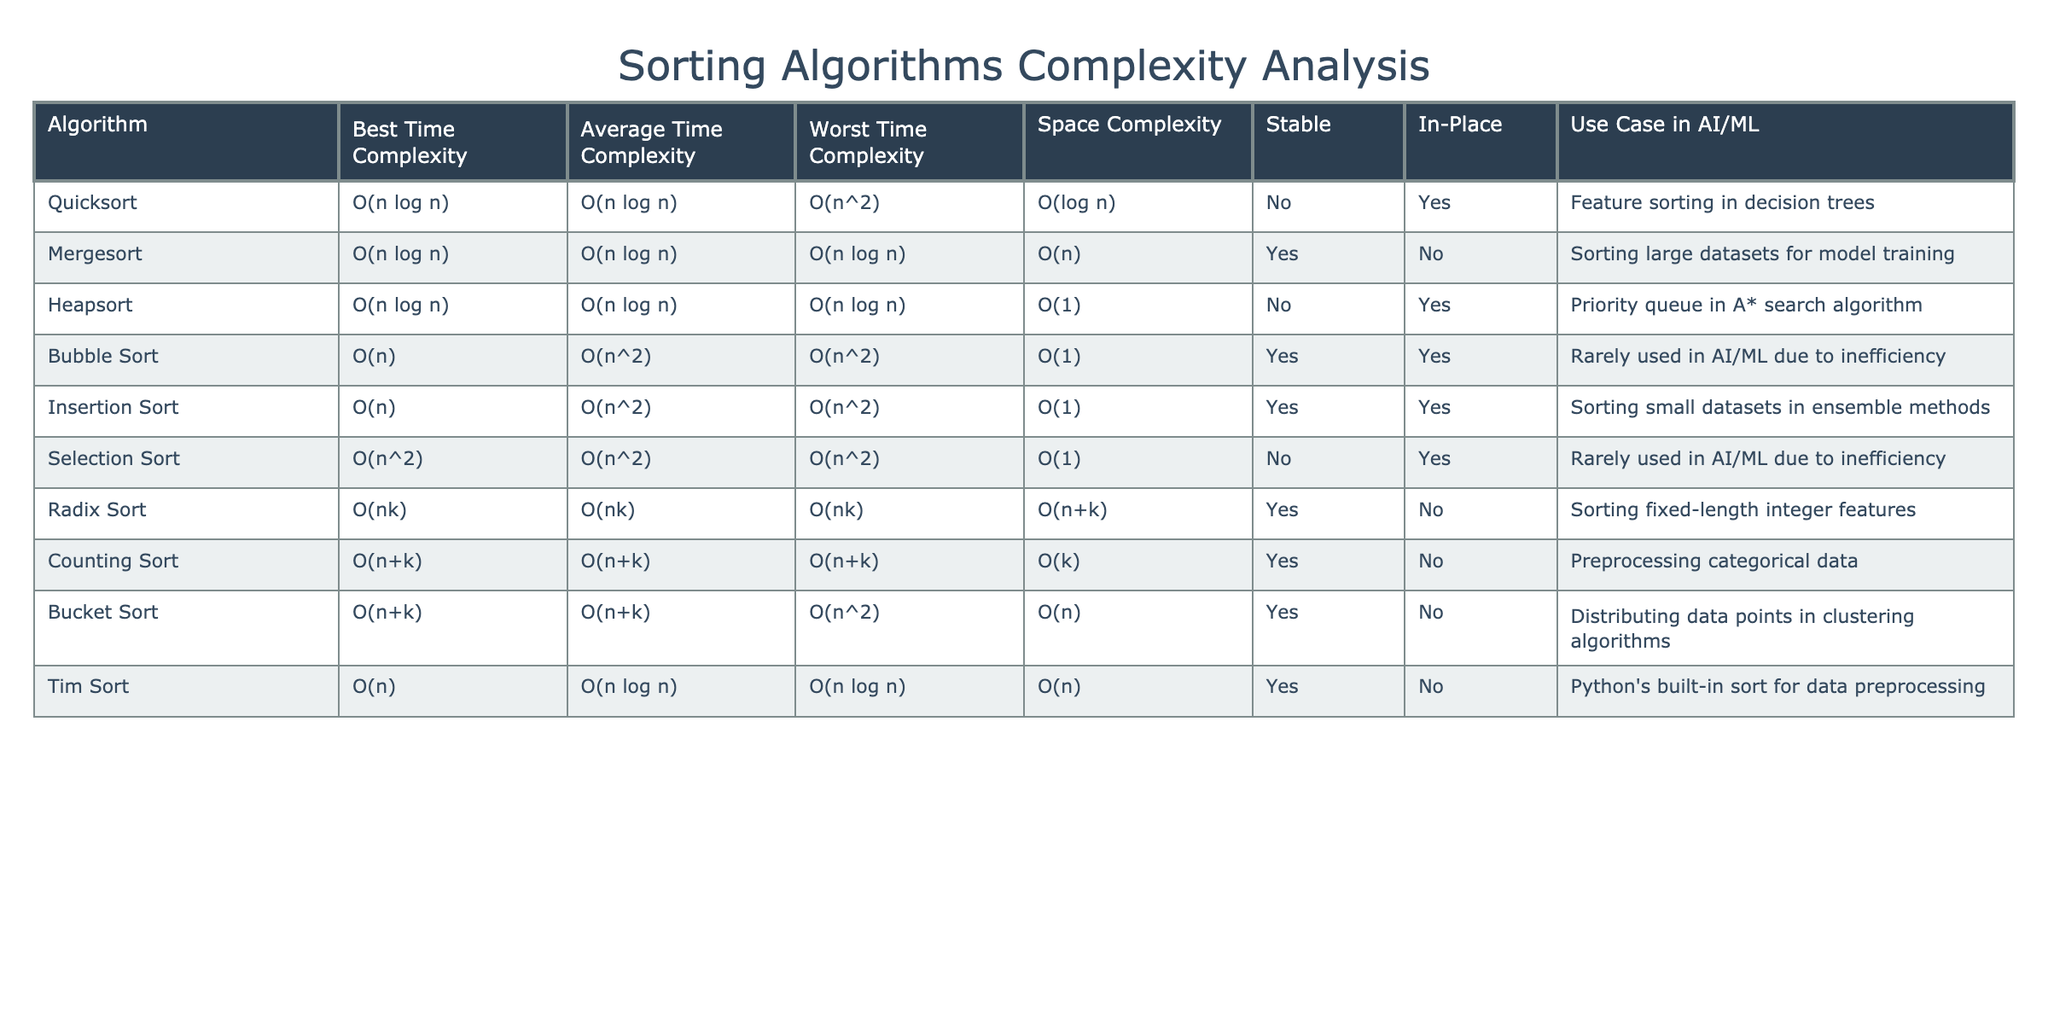What is the worst time complexity of Quick Sort? Looking at the table under the "Worst Time Complexity" column, the value corresponding to Quick Sort is O(n^2).
Answer: O(n^2) Which sorting algorithm is stable? By scanning the "Stable" column, we can check which algorithms have a "Yes" value. The algorithms marked as stable are Mergesort, Bubble Sort, Insertion Sort, Counting Sort, Bucket Sort, and Tim Sort.
Answer: Mergesort, Bubble Sort, Insertion Sort, Counting Sort, Bucket Sort, Tim Sort What is the average space complexity of Mergesort? From the "Space Complexity" column, the value for Mergesort is O(n).
Answer: O(n) Is Insertion Sort in-place? By looking at the "In-Place" column, it indicates a "Yes" for Insertion Sort, confirming that it is in-place.
Answer: Yes What is the difference in the worst time complexity between Bubble Sort and Insertion Sort? The worst time complexity of Bubble Sort is O(n^2) and for Insertion Sort is also O(n^2). Since both are the same, the difference is 0.
Answer: 0 Which algorithm has the best average time complexity? By scanning the "Average Time Complexity" column, we see that both Quick Sort and Mergesort have O(n log n), which is the best average time complexity among the listed sorting algorithms.
Answer: O(n log n) How many algorithms listed in the table are not stable? Looking at the "Stable" column, we find that Quick Sort, Heapsort, and Selection Sort have a "No" value, totaling three algorithms that are not stable.
Answer: 3 Which sorting algorithm is ideal for large datasets based on the space complexity? Mergesort has a space complexity of O(n), which is more manageable for large datasets compared to algorithms with higher space complexity. Therefore, Mergesort is suitable for large datasets.
Answer: Mergesort If we consider the use case of feature sorting in decision trees, which sorting algorithm is the best fit? Referring to the "Use Case in AI/ML" column, Quick Sort is explicitly mentioned for feature sorting in decision trees, making it the best fit for that use case.
Answer: Quick Sort What is the worst-case scenario for Counting Sort? The worst time complexity for Counting Sort listed in the table is O(n+k). Therefore, this represents the worst-case scenario for this algorithm.
Answer: O(n+k) If we need a sorting algorithm that works well with fixed-length integer features, which should we choose? By looking into the "Use Case in AI/ML" column, Radix Sort is recommended for sorting fixed-length integer features.
Answer: Radix Sort 